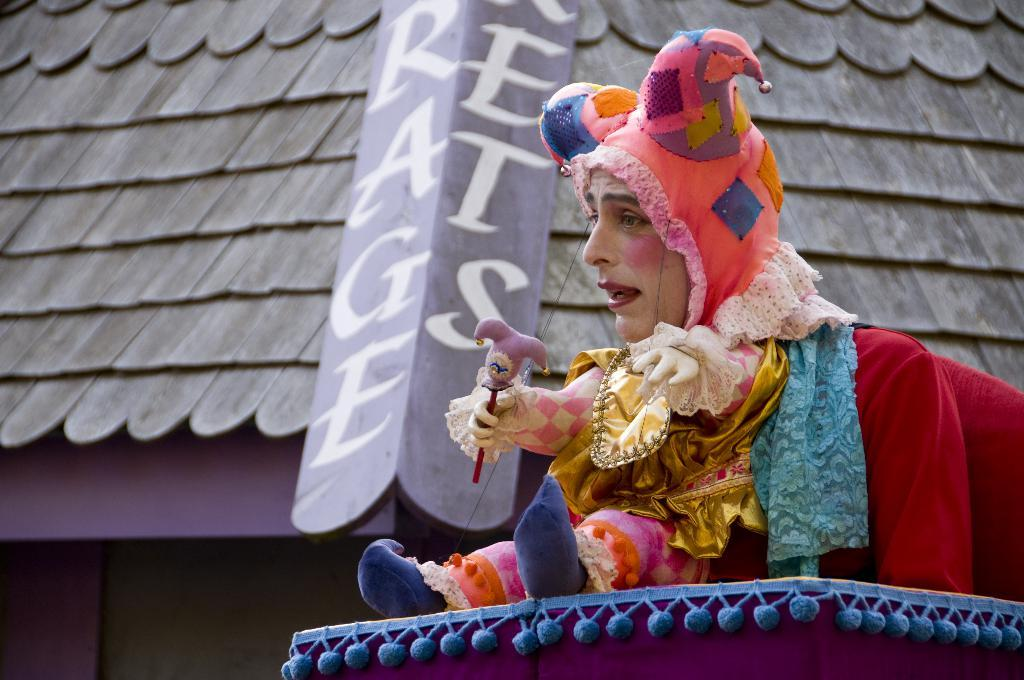What is the person in the image wearing? There is a person wearing a costume in the image. What can be seen in the background of the image? There is a shed in the background of the image. Is there any text visible in the image? Yes, there is some text visible in the image. How many horns does the person have in the image? There is no mention of horns in the image. 